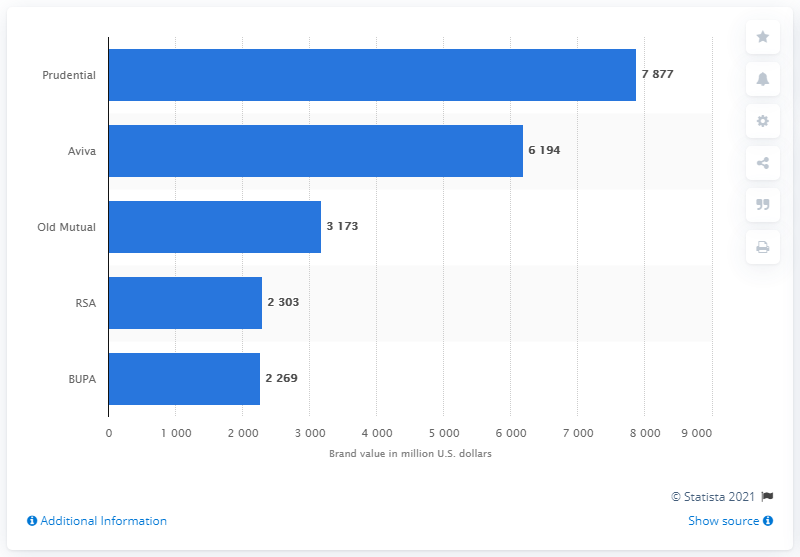What could be the reason for such differences in brand values among these companies? Several factors could account for the differences in brand values, including company size, global market penetration, brand age, financial performance, marketing strategies, customer perception, and economic factors specific to the industry and regions they operate in. 